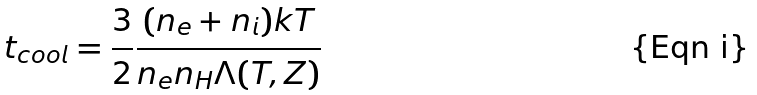Convert formula to latex. <formula><loc_0><loc_0><loc_500><loc_500>t _ { c o o l } = \frac { 3 } { 2 } \frac { ( n _ { e } + n _ { i } ) k T } { n _ { e } n _ { H } \Lambda ( T , Z ) }</formula> 